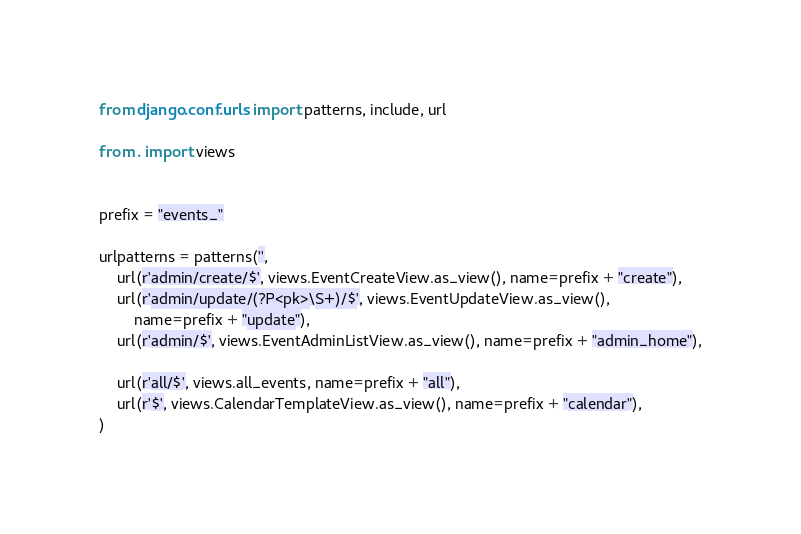Convert code to text. <code><loc_0><loc_0><loc_500><loc_500><_Python_>from django.conf.urls import patterns, include, url

from . import views


prefix = "events_"

urlpatterns = patterns('',
    url(r'admin/create/$', views.EventCreateView.as_view(), name=prefix + "create"),
    url(r'admin/update/(?P<pk>\S+)/$', views.EventUpdateView.as_view(), 
        name=prefix + "update"),
    url(r'admin/$', views.EventAdminListView.as_view(), name=prefix + "admin_home"),

    url(r'all/$', views.all_events, name=prefix + "all"),
    url(r'$', views.CalendarTemplateView.as_view(), name=prefix + "calendar"),
)
</code> 